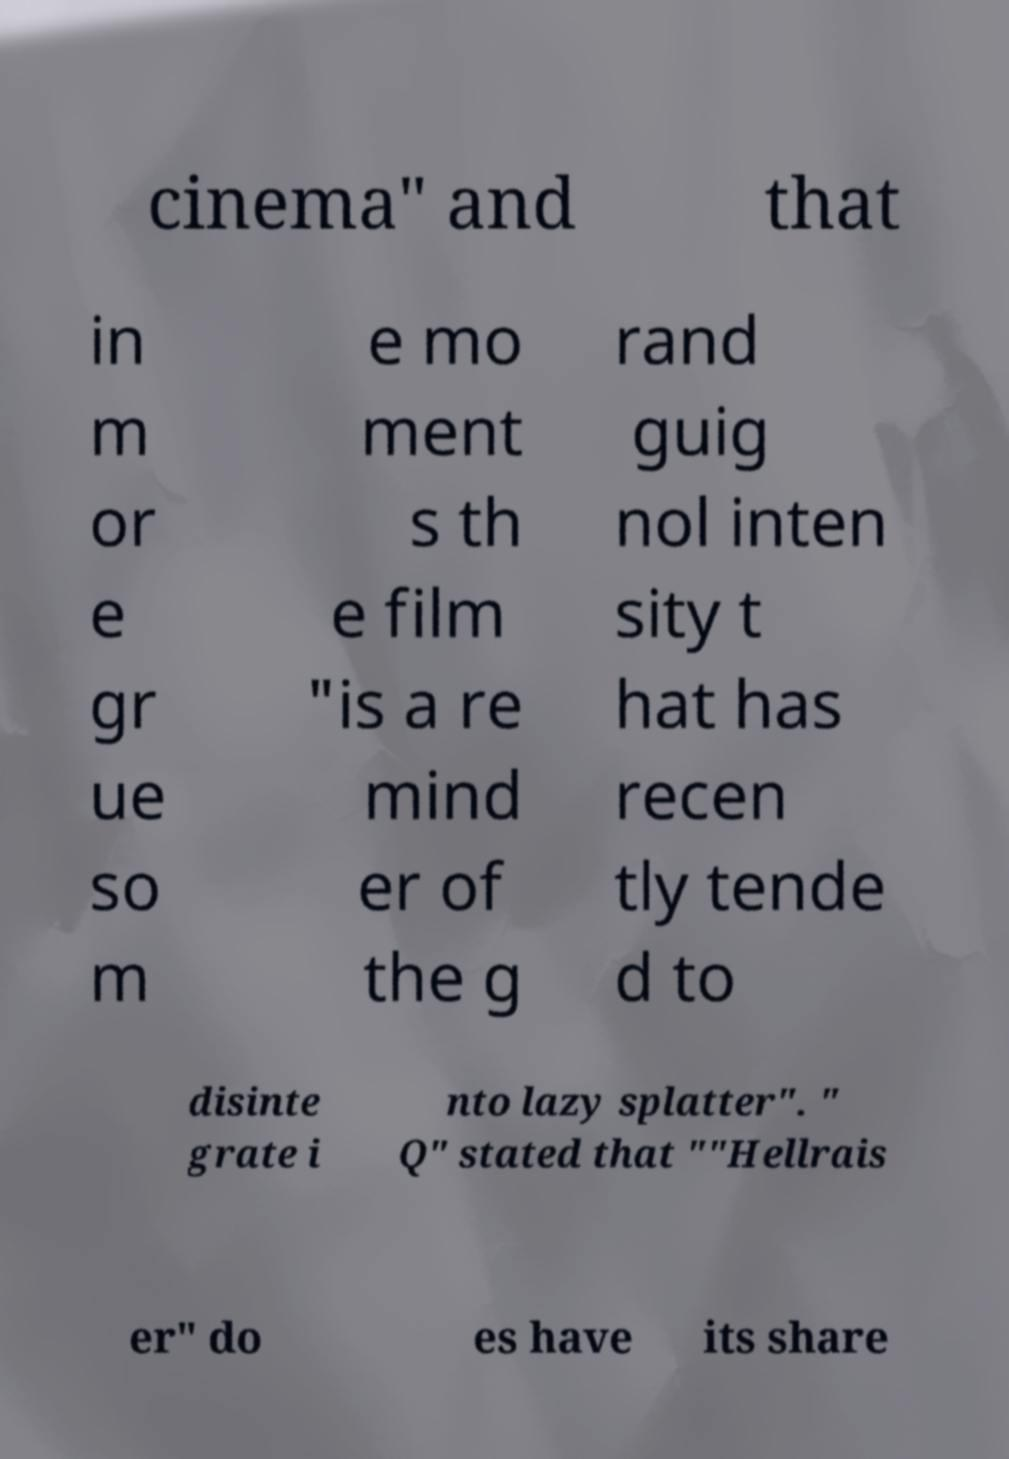Can you accurately transcribe the text from the provided image for me? cinema" and that in m or e gr ue so m e mo ment s th e film "is a re mind er of the g rand guig nol inten sity t hat has recen tly tende d to disinte grate i nto lazy splatter". " Q" stated that ""Hellrais er" do es have its share 